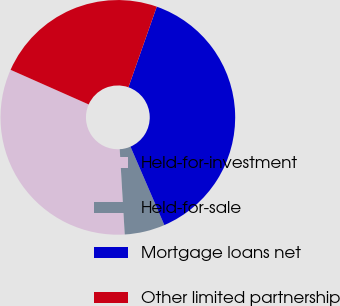<chart> <loc_0><loc_0><loc_500><loc_500><pie_chart><fcel>Held-for-investment<fcel>Held-for-sale<fcel>Mortgage loans net<fcel>Other limited partnership<nl><fcel>32.58%<fcel>5.55%<fcel>38.13%<fcel>23.74%<nl></chart> 